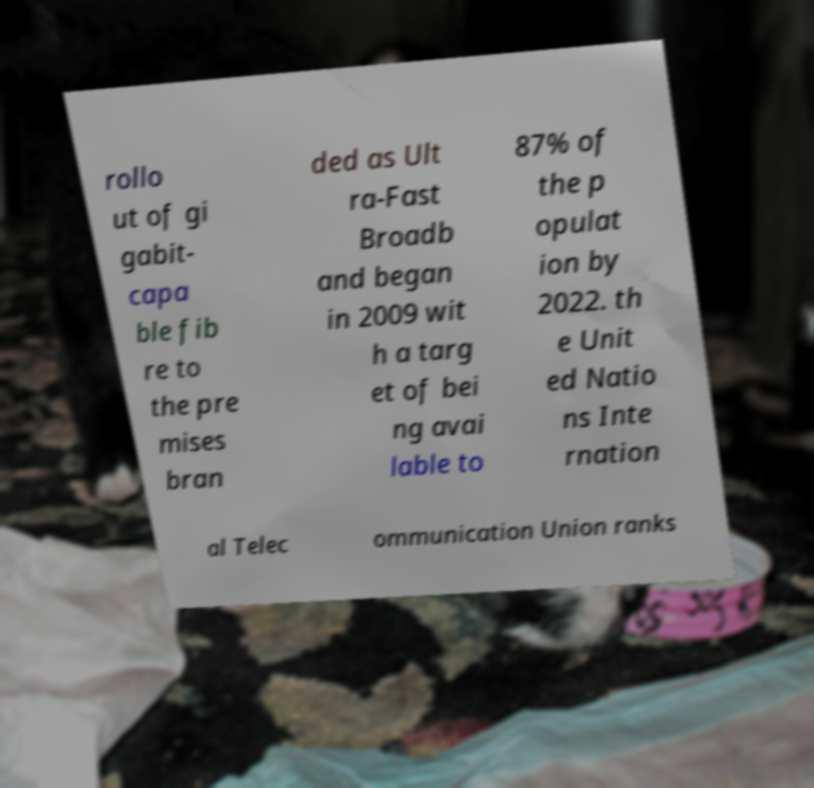Can you accurately transcribe the text from the provided image for me? rollo ut of gi gabit- capa ble fib re to the pre mises bran ded as Ult ra-Fast Broadb and began in 2009 wit h a targ et of bei ng avai lable to 87% of the p opulat ion by 2022. th e Unit ed Natio ns Inte rnation al Telec ommunication Union ranks 